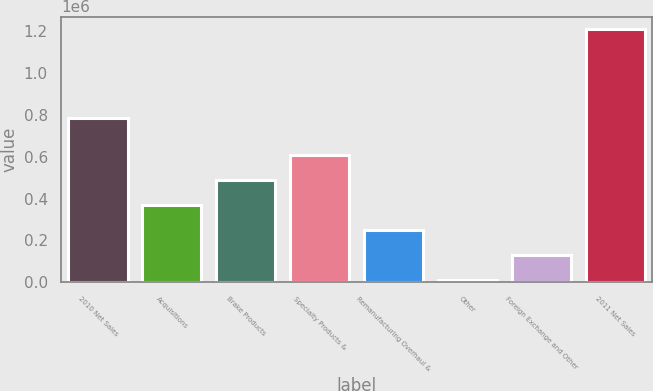Convert chart to OTSL. <chart><loc_0><loc_0><loc_500><loc_500><bar_chart><fcel>2010 Net Sales<fcel>Acquisitions<fcel>Brake Products<fcel>Specialty Products &<fcel>Remanufacturing Overhaul &<fcel>Other<fcel>Foreign Exchange and Other<fcel>2011 Net Sales<nl><fcel>784504<fcel>369194<fcel>489318<fcel>609442<fcel>249071<fcel>8824<fcel>128948<fcel>1.21006e+06<nl></chart> 